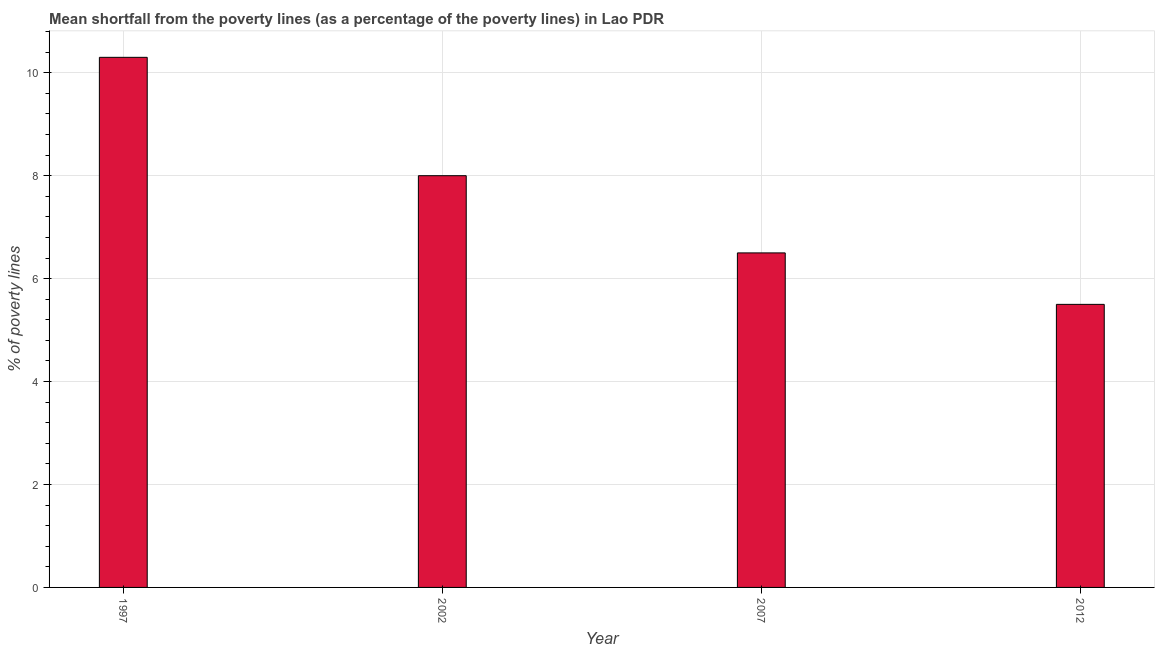Does the graph contain any zero values?
Keep it short and to the point. No. Does the graph contain grids?
Give a very brief answer. Yes. What is the title of the graph?
Provide a succinct answer. Mean shortfall from the poverty lines (as a percentage of the poverty lines) in Lao PDR. What is the label or title of the Y-axis?
Provide a succinct answer. % of poverty lines. What is the poverty gap at national poverty lines in 2002?
Your response must be concise. 8. In which year was the poverty gap at national poverty lines maximum?
Your response must be concise. 1997. In which year was the poverty gap at national poverty lines minimum?
Your response must be concise. 2012. What is the sum of the poverty gap at national poverty lines?
Ensure brevity in your answer.  30.3. What is the difference between the poverty gap at national poverty lines in 1997 and 2007?
Your answer should be very brief. 3.8. What is the average poverty gap at national poverty lines per year?
Offer a very short reply. 7.58. What is the median poverty gap at national poverty lines?
Provide a succinct answer. 7.25. Do a majority of the years between 2002 and 2007 (inclusive) have poverty gap at national poverty lines greater than 4.8 %?
Your response must be concise. Yes. What is the ratio of the poverty gap at national poverty lines in 2002 to that in 2007?
Your answer should be compact. 1.23. What is the difference between the highest and the second highest poverty gap at national poverty lines?
Keep it short and to the point. 2.3. Is the sum of the poverty gap at national poverty lines in 2002 and 2007 greater than the maximum poverty gap at national poverty lines across all years?
Make the answer very short. Yes. What is the difference between the highest and the lowest poverty gap at national poverty lines?
Provide a succinct answer. 4.8. How many years are there in the graph?
Provide a short and direct response. 4. What is the difference between two consecutive major ticks on the Y-axis?
Ensure brevity in your answer.  2. What is the % of poverty lines in 2007?
Keep it short and to the point. 6.5. What is the difference between the % of poverty lines in 2007 and 2012?
Offer a terse response. 1. What is the ratio of the % of poverty lines in 1997 to that in 2002?
Give a very brief answer. 1.29. What is the ratio of the % of poverty lines in 1997 to that in 2007?
Offer a terse response. 1.58. What is the ratio of the % of poverty lines in 1997 to that in 2012?
Keep it short and to the point. 1.87. What is the ratio of the % of poverty lines in 2002 to that in 2007?
Offer a terse response. 1.23. What is the ratio of the % of poverty lines in 2002 to that in 2012?
Offer a terse response. 1.46. What is the ratio of the % of poverty lines in 2007 to that in 2012?
Your response must be concise. 1.18. 